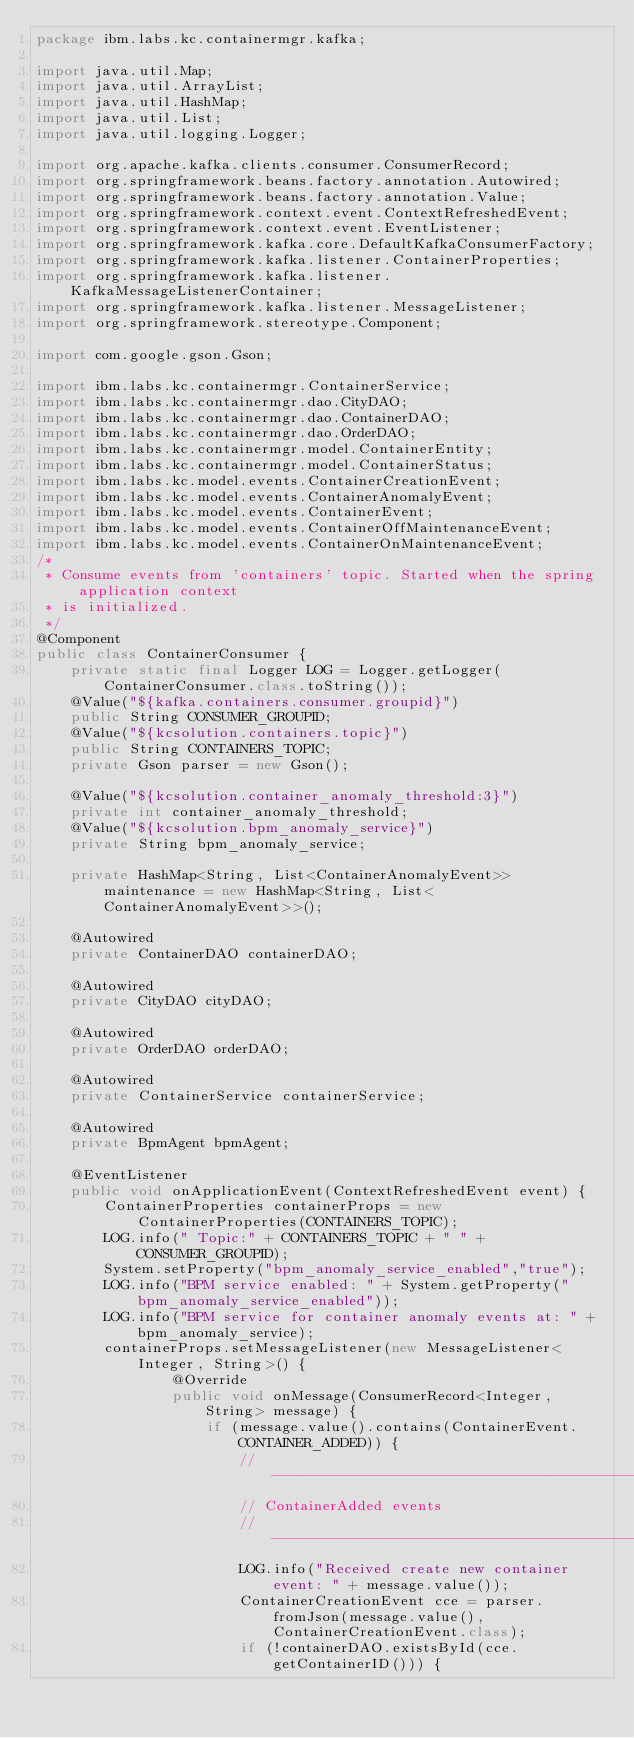<code> <loc_0><loc_0><loc_500><loc_500><_Java_>package ibm.labs.kc.containermgr.kafka;

import java.util.Map;
import java.util.ArrayList;
import java.util.HashMap;
import java.util.List;
import java.util.logging.Logger;

import org.apache.kafka.clients.consumer.ConsumerRecord;
import org.springframework.beans.factory.annotation.Autowired;
import org.springframework.beans.factory.annotation.Value;
import org.springframework.context.event.ContextRefreshedEvent;
import org.springframework.context.event.EventListener;
import org.springframework.kafka.core.DefaultKafkaConsumerFactory;
import org.springframework.kafka.listener.ContainerProperties;
import org.springframework.kafka.listener.KafkaMessageListenerContainer;
import org.springframework.kafka.listener.MessageListener;
import org.springframework.stereotype.Component;

import com.google.gson.Gson;

import ibm.labs.kc.containermgr.ContainerService;
import ibm.labs.kc.containermgr.dao.CityDAO;
import ibm.labs.kc.containermgr.dao.ContainerDAO;
import ibm.labs.kc.containermgr.dao.OrderDAO;
import ibm.labs.kc.containermgr.model.ContainerEntity;
import ibm.labs.kc.containermgr.model.ContainerStatus;
import ibm.labs.kc.model.events.ContainerCreationEvent;
import ibm.labs.kc.model.events.ContainerAnomalyEvent;
import ibm.labs.kc.model.events.ContainerEvent;
import ibm.labs.kc.model.events.ContainerOffMaintenanceEvent;
import ibm.labs.kc.model.events.ContainerOnMaintenanceEvent;
/*
 * Consume events from 'containers' topic. Started when the spring application context
 * is initialized.
 */
@Component
public class ContainerConsumer {
	private static final Logger LOG = Logger.getLogger(ContainerConsumer.class.toString());
	@Value("${kafka.containers.consumer.groupid}")
	public String CONSUMER_GROUPID;
	@Value("${kcsolution.containers.topic}")
  	public String CONTAINERS_TOPIC;
	private Gson parser = new Gson();

	@Value("${kcsolution.container_anomaly_threshold:3}")
	private int container_anomaly_threshold;
	@Value("${kcsolution.bpm_anomaly_service}")
	private String bpm_anomaly_service;

	private HashMap<String, List<ContainerAnomalyEvent>> maintenance = new HashMap<String, List<ContainerAnomalyEvent>>();

	@Autowired
	private ContainerDAO containerDAO;

	@Autowired
	private CityDAO cityDAO;

	@Autowired
	private OrderDAO orderDAO;

	@Autowired
	private ContainerService containerService;

	@Autowired
	private BpmAgent bpmAgent;

	@EventListener
    public void onApplicationEvent(ContextRefreshedEvent event) {
		ContainerProperties containerProps = new ContainerProperties(CONTAINERS_TOPIC);
		LOG.info(" Topic:" + CONTAINERS_TOPIC + " " + CONSUMER_GROUPID);
		System.setProperty("bpm_anomaly_service_enabled","true");
		LOG.info("BPM service enabled: " + System.getProperty("bpm_anomaly_service_enabled"));
		LOG.info("BPM service for container anomaly events at: " + bpm_anomaly_service);
		containerProps.setMessageListener(new MessageListener<Integer, String>() {
		        @Override
		        public void onMessage(ConsumerRecord<Integer, String> message) {
		        	if (message.value().contains(ContainerEvent.CONTAINER_ADDED)) {
						// --------------------------------------------
						// ContainerAdded events
						//---------------------------------------------
						LOG.info("Received create new container event: " + message.value());
						ContainerCreationEvent cce = parser.fromJson(message.value(), ContainerCreationEvent.class);
						if (!containerDAO.existsById(cce.getContainerID())) {</code> 